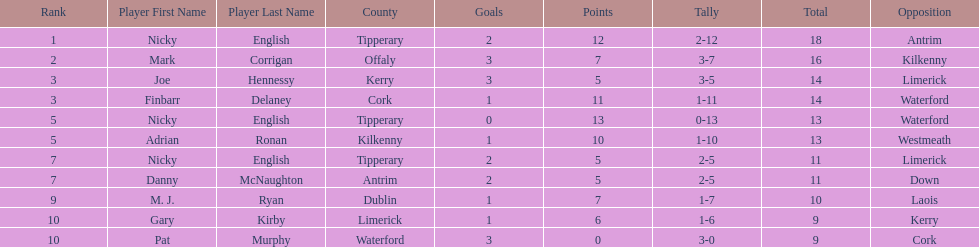Who was the top ranked player in a single game? Nicky English. 